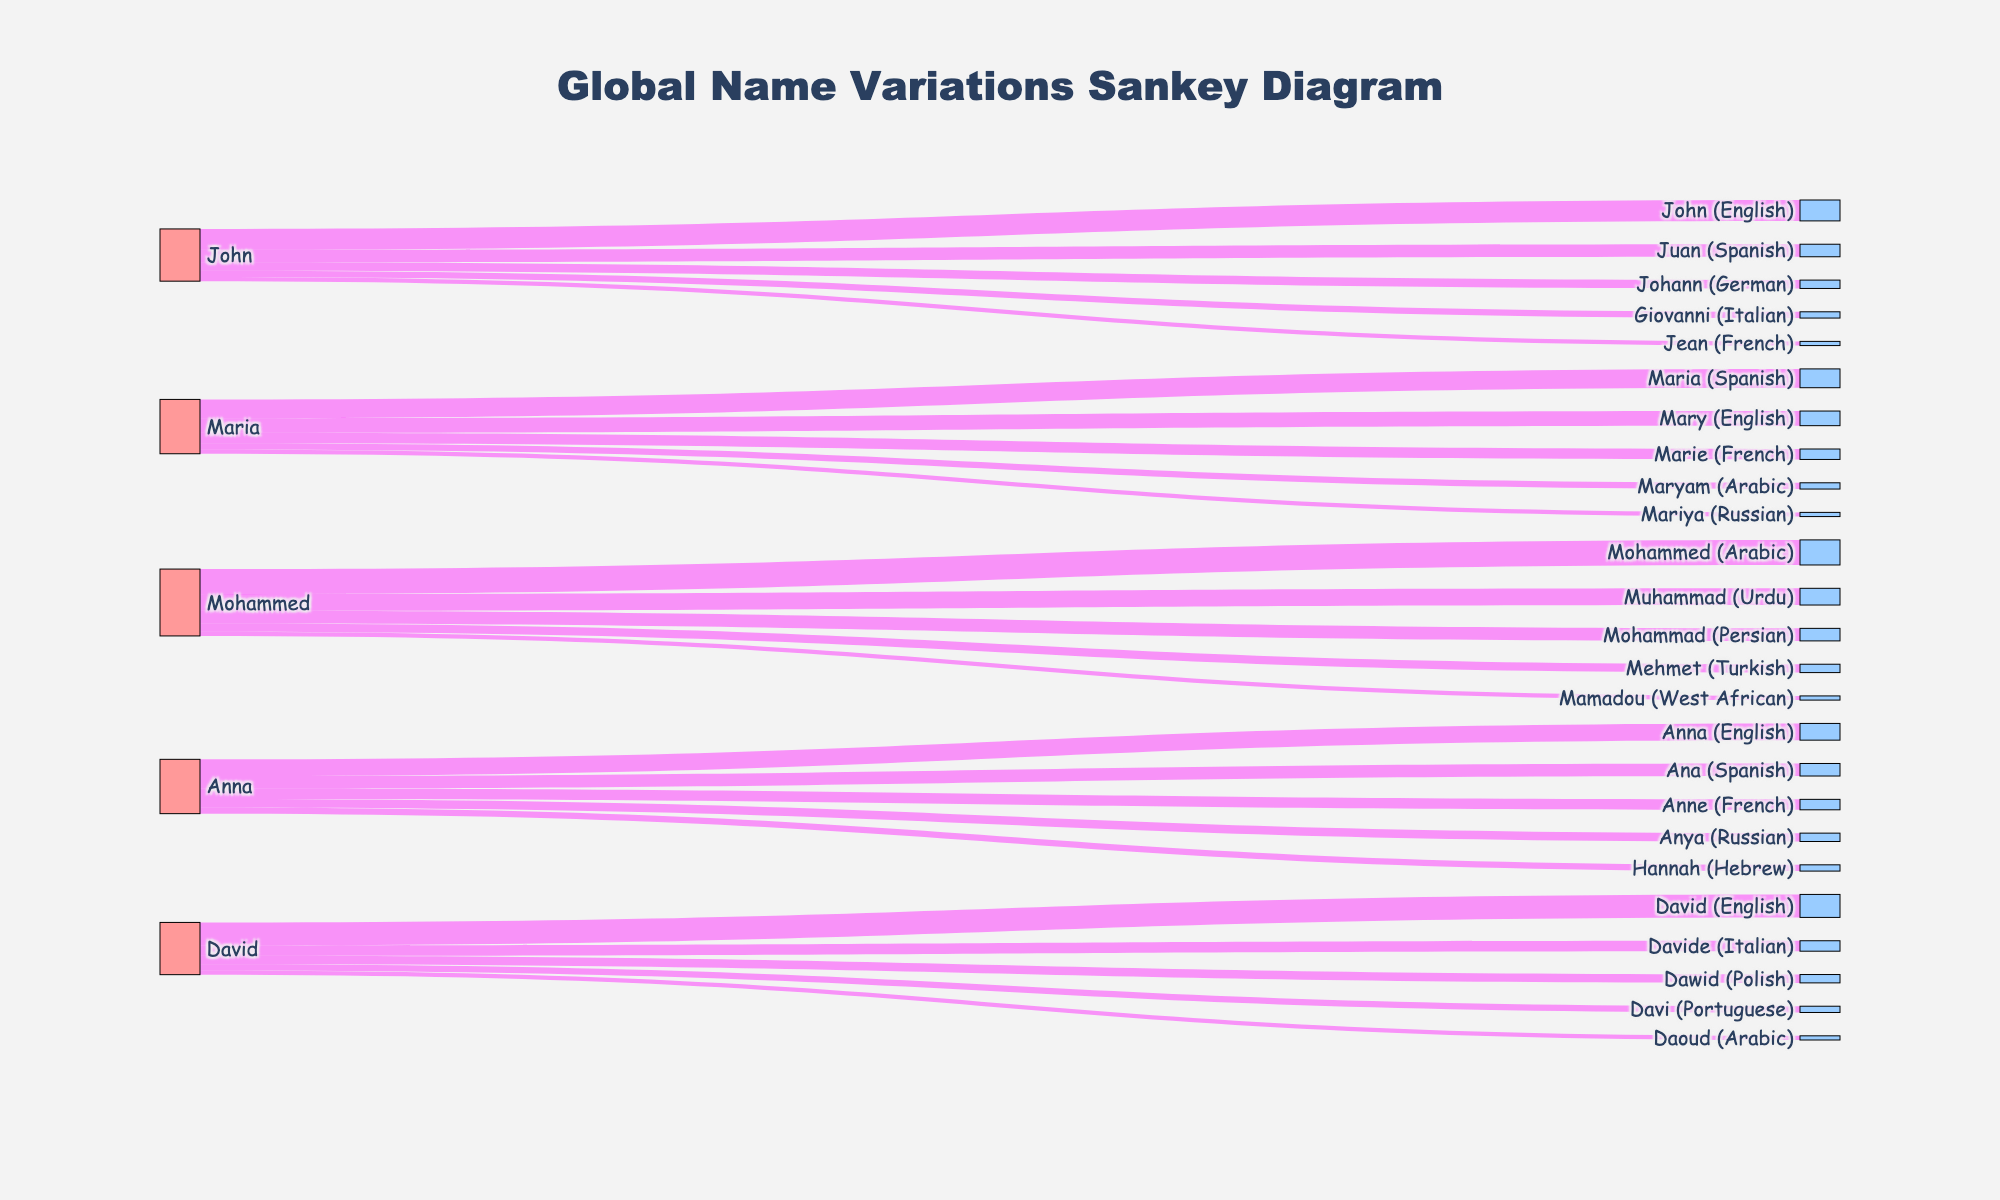What is the title of the Sankey diagram? The title of the diagram is typically located at the top of the figure. In this case, the title is placed centrally with a specific font.
Answer: Global Name Variations Sankey Diagram How many variations of the name "John" are represented in the diagram? To find the number of variations, look for all the different target names connected to "John" as the source node in the diagram.
Answer: 5 What is the total value associated with the name "Maria"? Sum all the values linked from "Maria" to its variations. These are 45, 35, 25, 15, and 10. The total is 45 + 35 + 25 + 15 + 10.
Answer: 130 Which variation of "Mohammed" has the highest value? By examining the Sankey diagram, compare the values of different variations linked to "Mohammed". The highest value among 60, 40, 30, 20, and 10 is 60.
Answer: Mohammed (Arabic) How many nodes are there in total in the Sankey diagram? The total number of nodes includes all the unique sources and targets in the diagram. By counting all distinct names in both the source and target columns: 5 sources + 25 targets.
Answer: 30 What is the difference between the values of "Anna" and "David"? Sum up the values of variations for each name. For "Anna": 40 + 30 + 25 + 20 + 15 = 130. For "David": 55 + 25 + 20 + 15 + 10 = 125. The difference is 130 - 125.
Answer: 5 Which two names have variations in the most distinct languages? Check the number of different targets each source name is linked to and identify those with the highest count. Both "Maria" and "Mohammed" each have 5 variations.
Answer: Maria and Mohammed What is the average value of "John's" variations? Sum up the values of "John" variations (50, 30, 20, 15, 10) and divide by the number of variations (5): (50 + 30 + 20 + 15 + 10)/5.
Answer: 25 Among "David," "John," and "Anna," which name has the highest total value across all its variations? Sum the values for each name's variations: "John": 50 + 30 + 20 + 15 + 10 = 125, "David": 55 + 25 + 20 + 15 + 10 = 125, "Anna": 40 + 30 + 25 + 20 + 15 = 130. The highest value is for "Anna".
Answer: Anna 